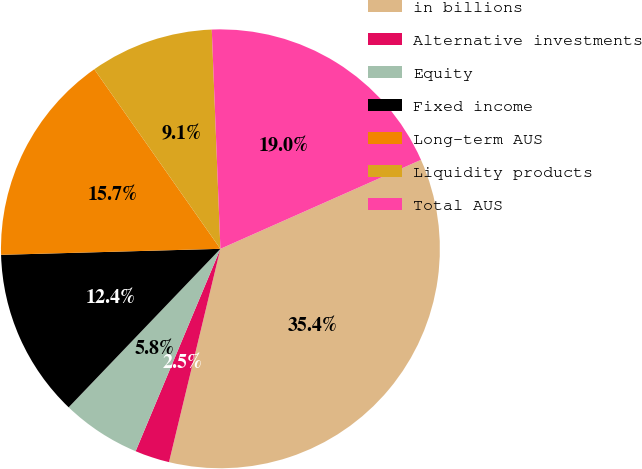Convert chart. <chart><loc_0><loc_0><loc_500><loc_500><pie_chart><fcel>in billions<fcel>Alternative investments<fcel>Equity<fcel>Fixed income<fcel>Long-term AUS<fcel>Liquidity products<fcel>Total AUS<nl><fcel>35.41%<fcel>2.55%<fcel>5.84%<fcel>12.41%<fcel>15.69%<fcel>9.12%<fcel>18.98%<nl></chart> 